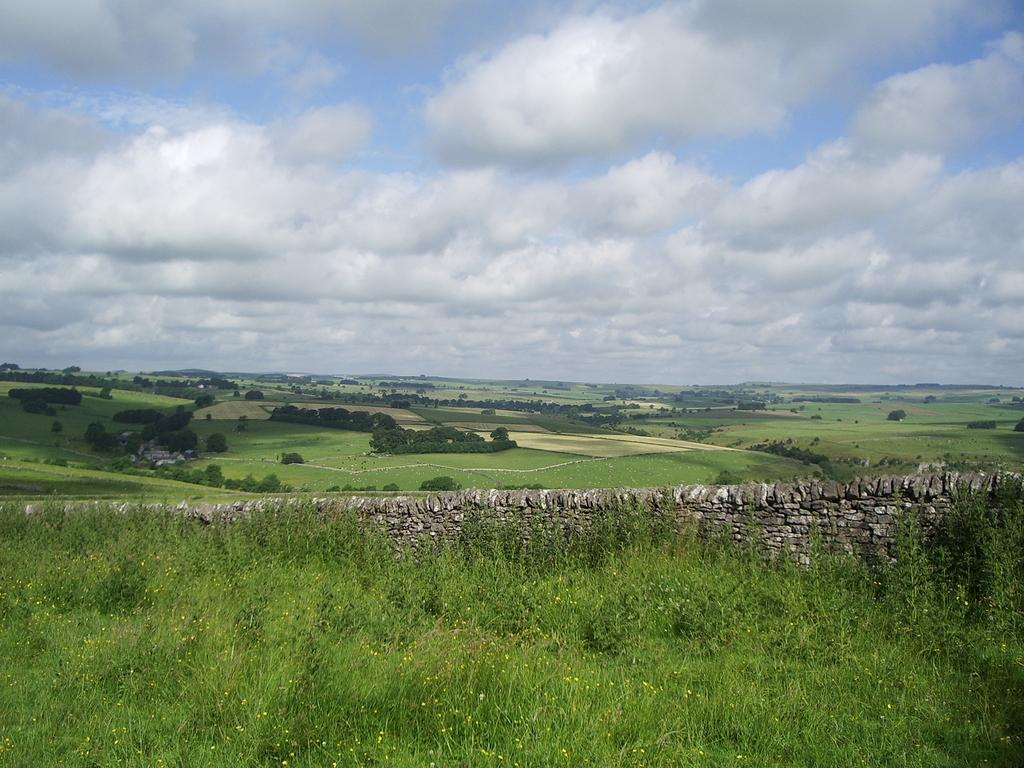Where was the picture taken? The picture was clicked outside. What can be seen in the foreground of the image? There is green grass, plants, and rocks in the foreground. What is visible in the background of the image? The sky is visible in the background. What is the condition of the sky in the image? The sky is full of clouds. Can you see a fireman holding a stick in the image? There is no fireman or stick present in the image. 